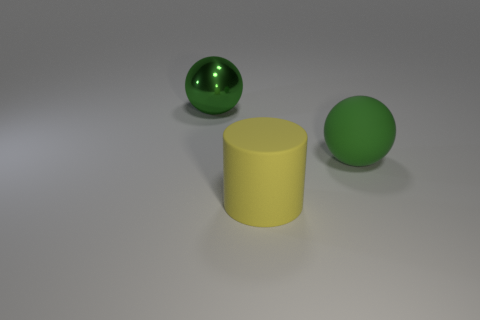What number of other objects are there of the same shape as the big yellow matte object?
Give a very brief answer. 0. What is the material of the thing that is the same color as the large shiny sphere?
Your answer should be compact. Rubber. What number of big matte things are the same color as the big metal sphere?
Offer a very short reply. 1. There is a ball that is the same material as the large cylinder; what is its color?
Your answer should be very brief. Green. Are there any metallic spheres that have the same size as the green metal object?
Your response must be concise. No. Is the number of large balls that are to the left of the yellow cylinder greater than the number of rubber objects on the left side of the large green matte ball?
Ensure brevity in your answer.  No. Is the object to the right of the matte cylinder made of the same material as the large green ball that is to the left of the big yellow rubber thing?
Make the answer very short. No. The green rubber thing that is the same size as the green metal thing is what shape?
Ensure brevity in your answer.  Sphere. Is there a brown matte thing that has the same shape as the large green metal thing?
Keep it short and to the point. No. There is a big ball on the left side of the large green matte object; is it the same color as the large sphere that is right of the big green metallic ball?
Your response must be concise. Yes. 